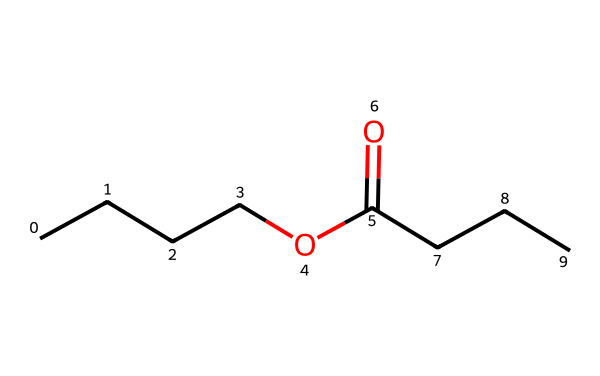What is the common name for this ester? The provided structure corresponds to butyl butyrate, which is the commonly recognized name for this compound.
Answer: butyl butyrate How many carbon atoms are in butyl butyrate? Analyzing the structure reveals the presence of a total of 6 carbon atoms; 4 in the butyl group and 2 in the butyric acid part of the ester.
Answer: 6 What type of functional group characterizes butyl butyrate? Butyl butyrate is characterized by the ester functional group, identified by the presence of the -COO- link within its structure.
Answer: ester What is the total number of hydrogen atoms in butyl butyrate? Counting the hydrogen atoms in the structure gives a total of 12; there are 2 from the butyl group and 10 from the remaining chain, considering the tetravalency of carbon.
Answer: 12 Which part of the structure determines the fruity aroma? The fruity aroma is determined by the ester functional group, specifically due to the alkyl groups attached, which in this case includes the butyl and butyrate components.
Answer: ester functional group How many oxygen atoms are present in butyl butyrate? The structure shows that there are 2 oxygen atoms present; one in the carbonyl (C=O) and another in the ether (C-O) part of the ester functional group.
Answer: 2 